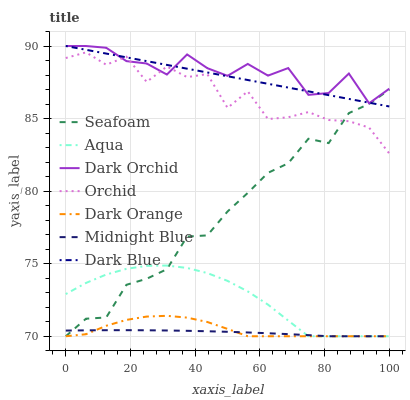Does Midnight Blue have the minimum area under the curve?
Answer yes or no. Yes. Does Dark Orchid have the maximum area under the curve?
Answer yes or no. Yes. Does Aqua have the minimum area under the curve?
Answer yes or no. No. Does Aqua have the maximum area under the curve?
Answer yes or no. No. Is Dark Blue the smoothest?
Answer yes or no. Yes. Is Orchid the roughest?
Answer yes or no. Yes. Is Midnight Blue the smoothest?
Answer yes or no. No. Is Midnight Blue the roughest?
Answer yes or no. No. Does Dark Orange have the lowest value?
Answer yes or no. Yes. Does Dark Orchid have the lowest value?
Answer yes or no. No. Does Dark Blue have the highest value?
Answer yes or no. Yes. Does Aqua have the highest value?
Answer yes or no. No. Is Aqua less than Dark Orchid?
Answer yes or no. Yes. Is Dark Blue greater than Dark Orange?
Answer yes or no. Yes. Does Dark Orchid intersect Orchid?
Answer yes or no. Yes. Is Dark Orchid less than Orchid?
Answer yes or no. No. Is Dark Orchid greater than Orchid?
Answer yes or no. No. Does Aqua intersect Dark Orchid?
Answer yes or no. No. 